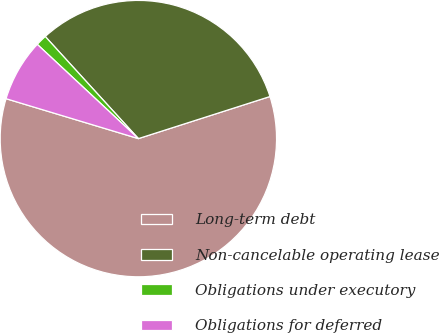Convert chart. <chart><loc_0><loc_0><loc_500><loc_500><pie_chart><fcel>Long-term debt<fcel>Non-cancelable operating lease<fcel>Obligations under executory<fcel>Obligations for deferred<nl><fcel>59.59%<fcel>31.84%<fcel>1.29%<fcel>7.28%<nl></chart> 